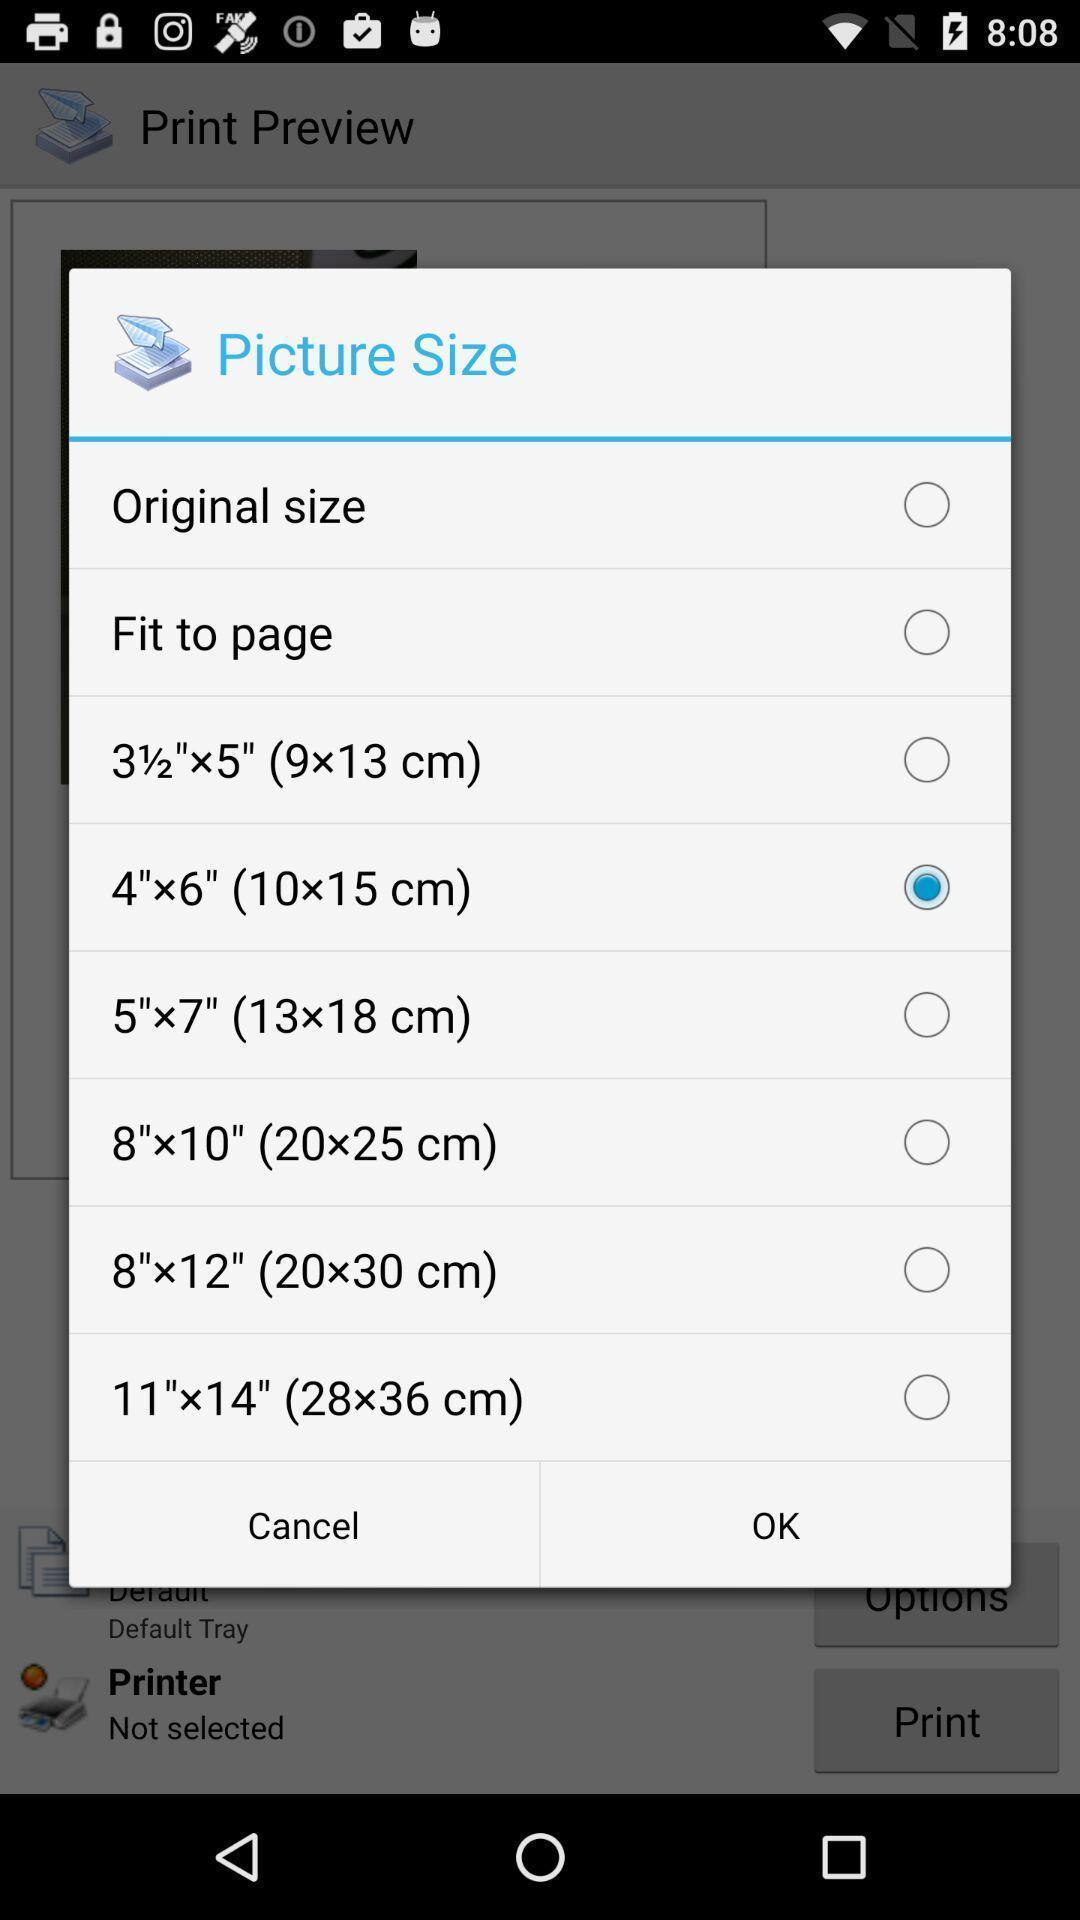Provide a description of this screenshot. Pop-up showing to select picture size. 